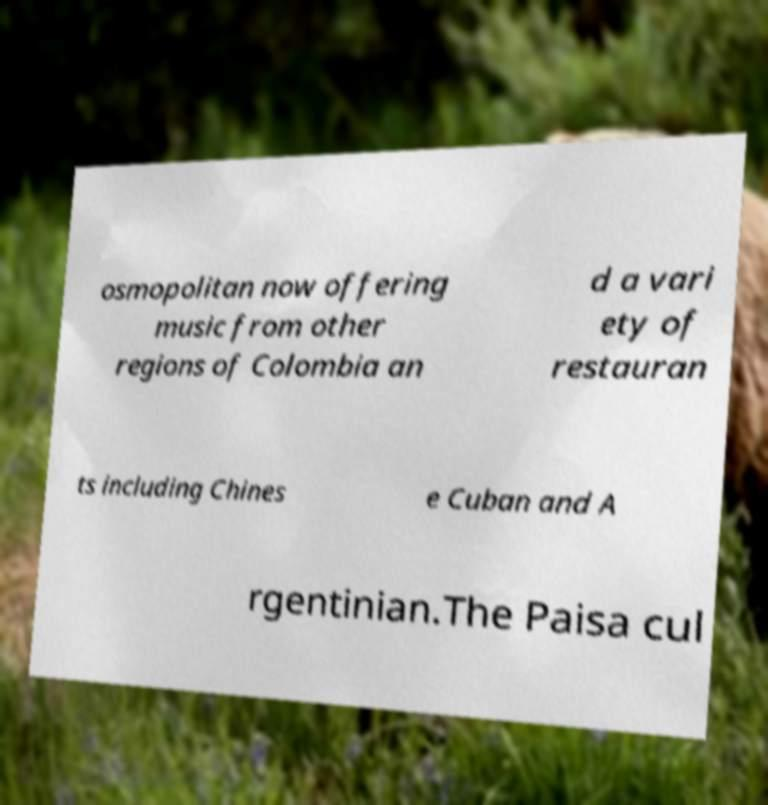Please read and relay the text visible in this image. What does it say? osmopolitan now offering music from other regions of Colombia an d a vari ety of restauran ts including Chines e Cuban and A rgentinian.The Paisa cul 